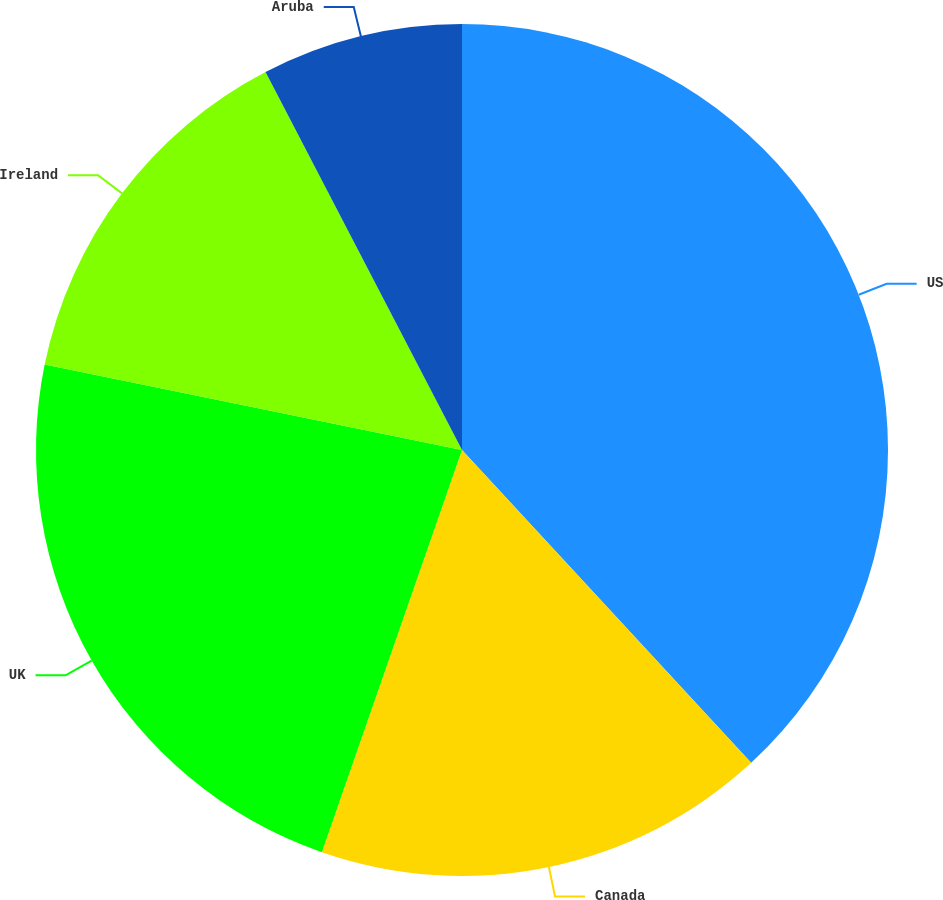Convert chart to OTSL. <chart><loc_0><loc_0><loc_500><loc_500><pie_chart><fcel>US<fcel>Canada<fcel>UK<fcel>Ireland<fcel>Aruba<nl><fcel>38.13%<fcel>17.21%<fcel>22.88%<fcel>14.16%<fcel>7.63%<nl></chart> 